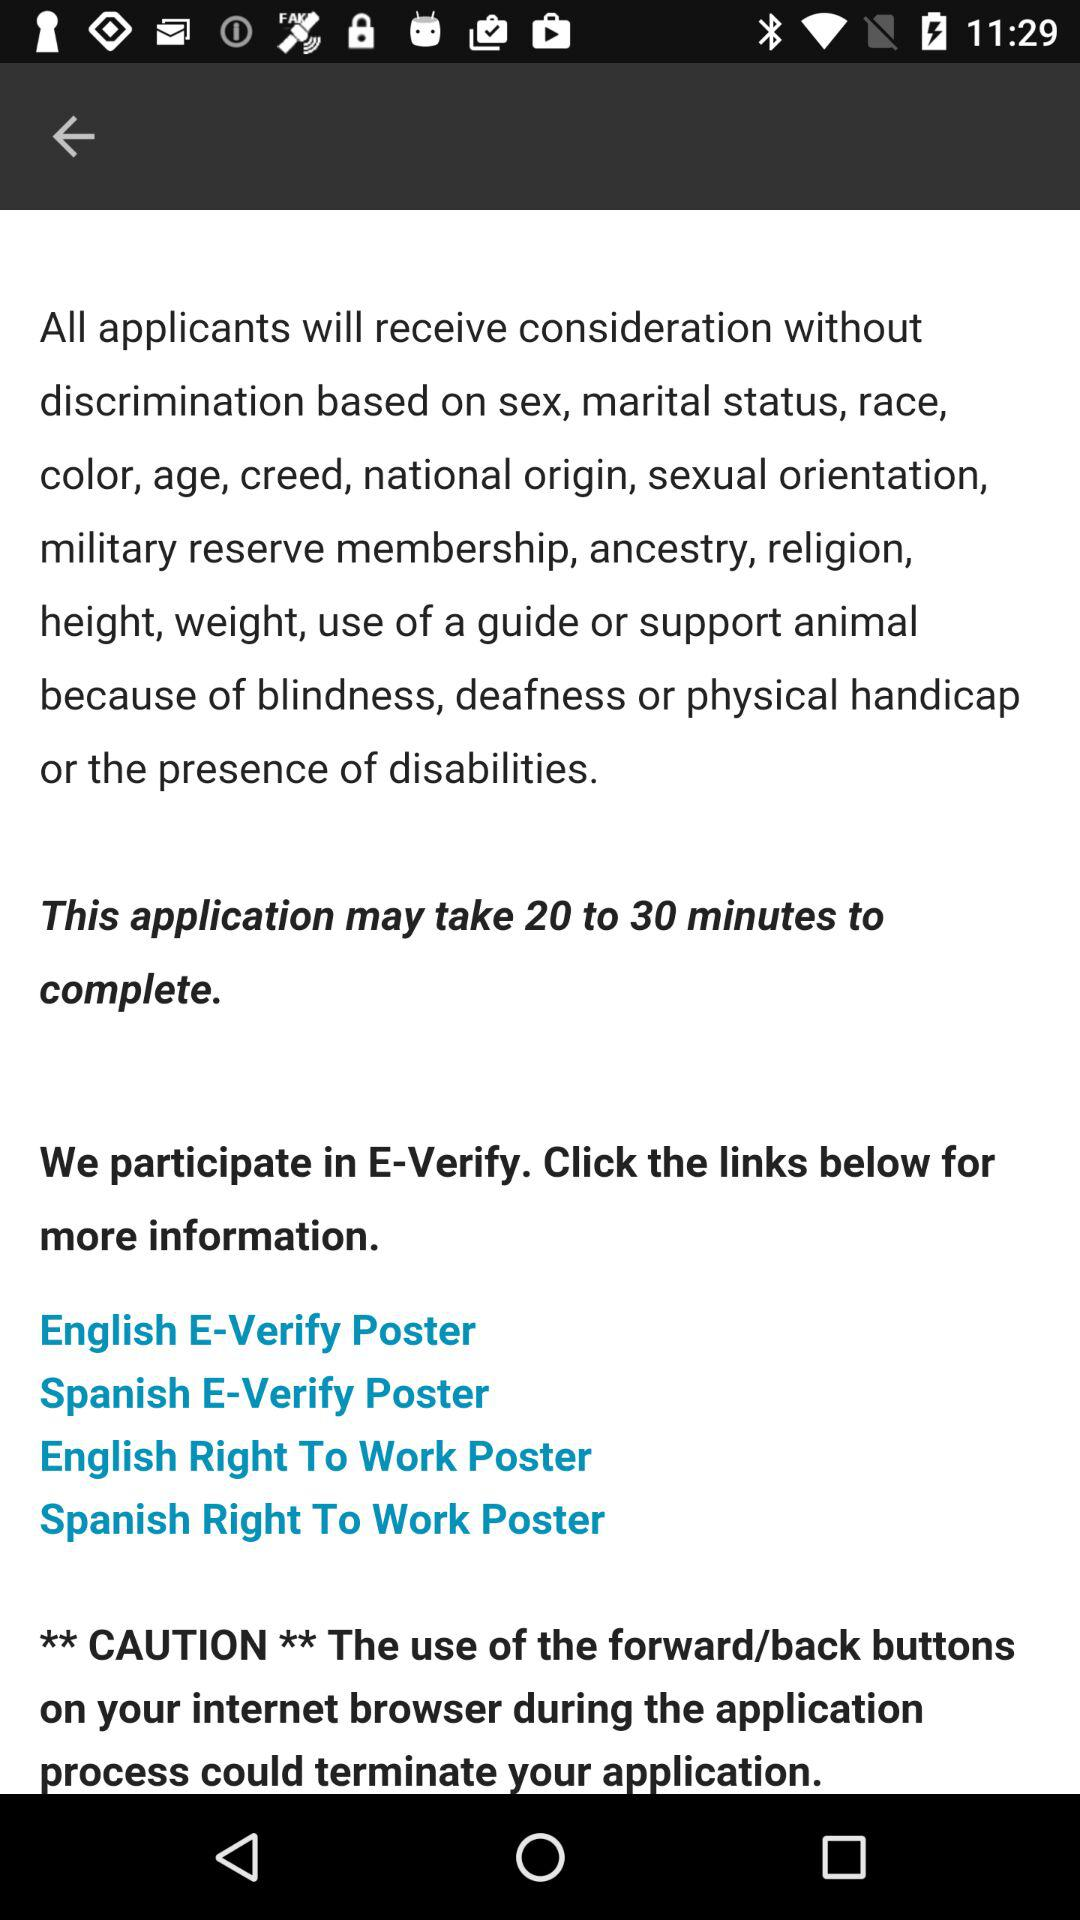How much time will the application take? The application will take 20 to 30 minutes. 